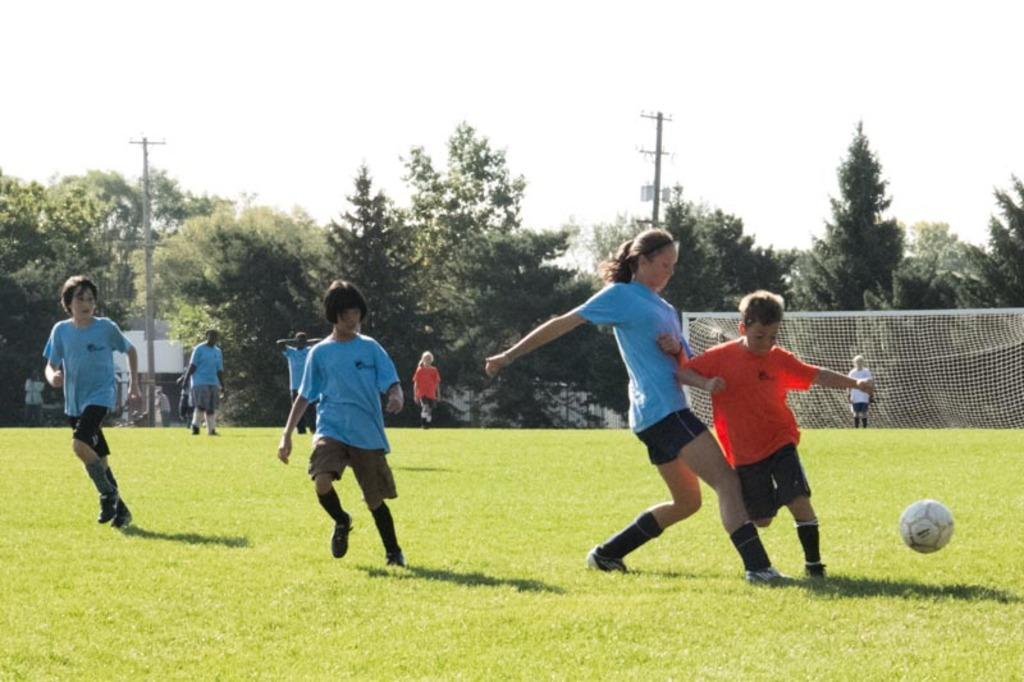Who is present in the image? There are children in the image. Where are the children located? The children are on the grass. What object is visible in the image that is commonly used for playing sports? There is a football in the image. What can be seen in the background of the image? There is a net, trees, two poles, and the sky visible in the background of the image. What type of pets are the children holding in the image? There are no pets visible in the image. The children are simply playing on the grass with a football. 